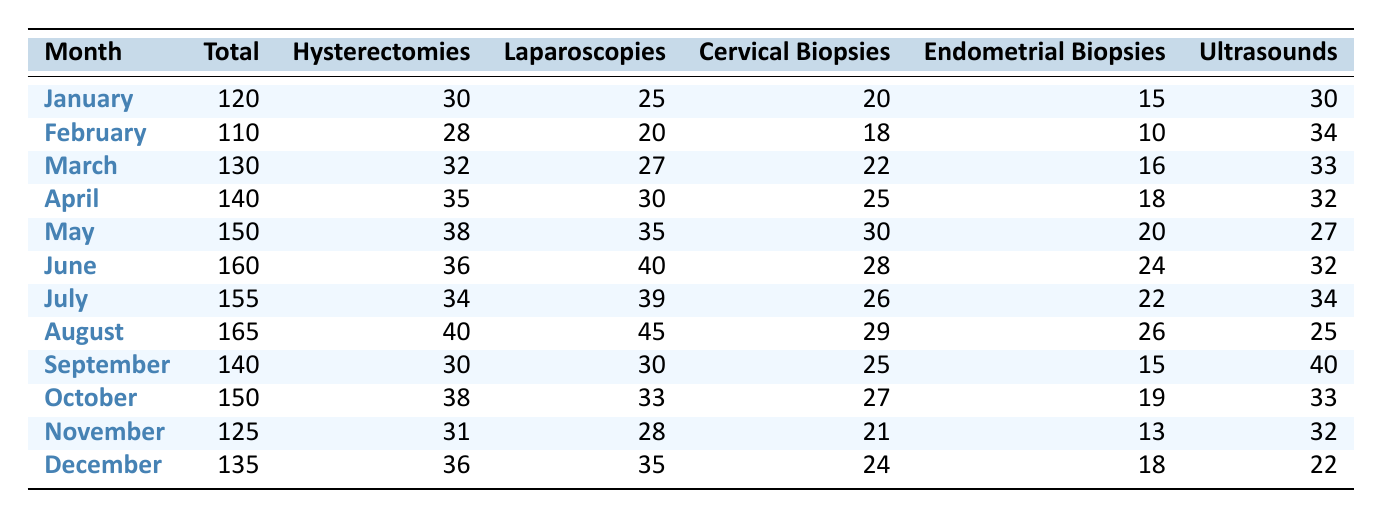What was the total number of procedures performed in June? Referring to the table, the total number of procedures listed for June is 160.
Answer: 160 Which month had the highest number of hysterectomies? By reviewing the hysterectomy counts for each month, August has the highest at 40.
Answer: 40 How many laparoscopies were performed in February and September combined? Adding the laparoscopies for February (20) and September (30), we compute 20 + 30 = 50.
Answer: 50 Did the total number of procedures increase from January to December? Comparing the total procedures in January (120) with December (135), we see an increase of 15.
Answer: Yes What is the average number of cervical biopsies performed per month in 2023? Summing the cervical biopsies for all months gives us 20 + 18 + 22 + 25 + 30 + 28 + 26 + 29 + 25 + 27 + 21 + 24 =  123. There are 12 months, so average = 123/12 = 10.25.
Answer: 10.25 Which month had the closest number of total procedures to the number performed in March? Total procedures in March is 130. Comparing nearby months: January (120), February (110), April (140), the closest count is April with 140.
Answer: 140 How many more ultrasounds were performed in July than in January? Referring to the table, July had 34 ultrasounds and January had 30. Thus, the difference is 34 - 30 = 4.
Answer: 4 In which month did endometrial biopsies decrease compared to the previous month? Comparing each month, January had 15 and February had 10, showing a decrease of 5.
Answer: February What is the total number of procedures performed in the first half of the year? Summing the total procedures from January to June gives us 120 + 110 + 130 + 140 + 150 + 160 = 810.
Answer: 810 